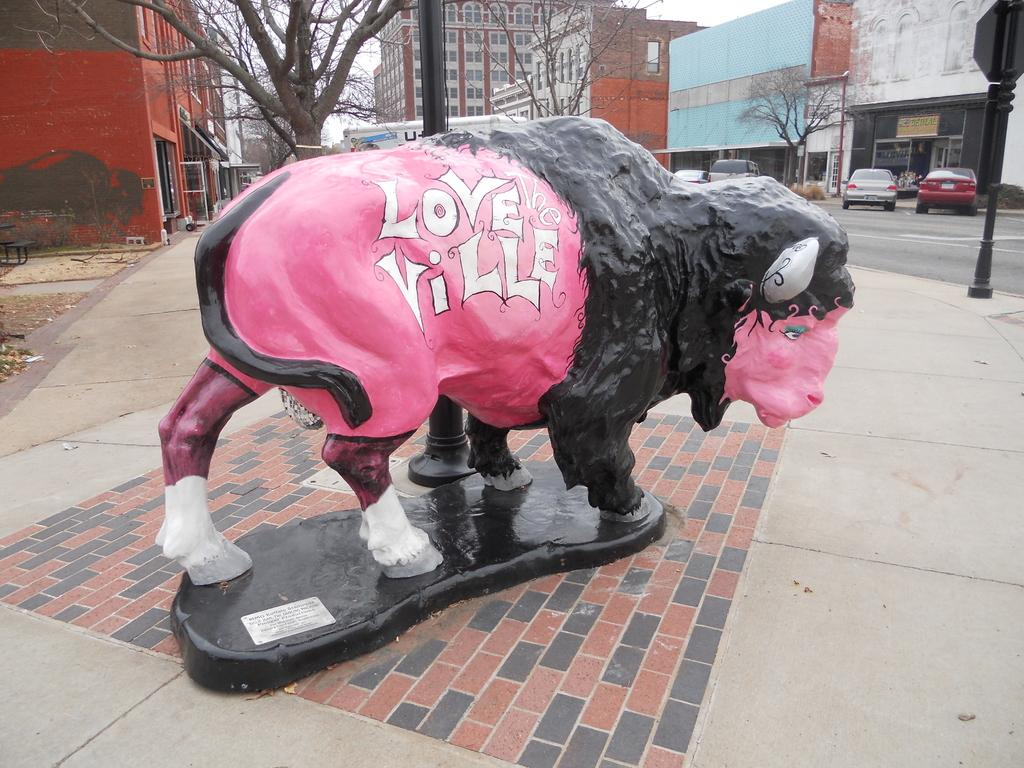What is depicted on the pavement in the image? There is a depiction of a sheep on the pavement. What can be seen on the side of the road in the image? There are vehicles parked on the side of a road. What is visible in the background of the image? There are buildings and trees in the background of the image. Can you tell me how many people are kissing in the image? There is no indication of kissing or any people in the image; it features a depiction of a sheep on the pavement and parked vehicles. What type of oatmeal is being served in the image? There is no oatmeal present in the image. 